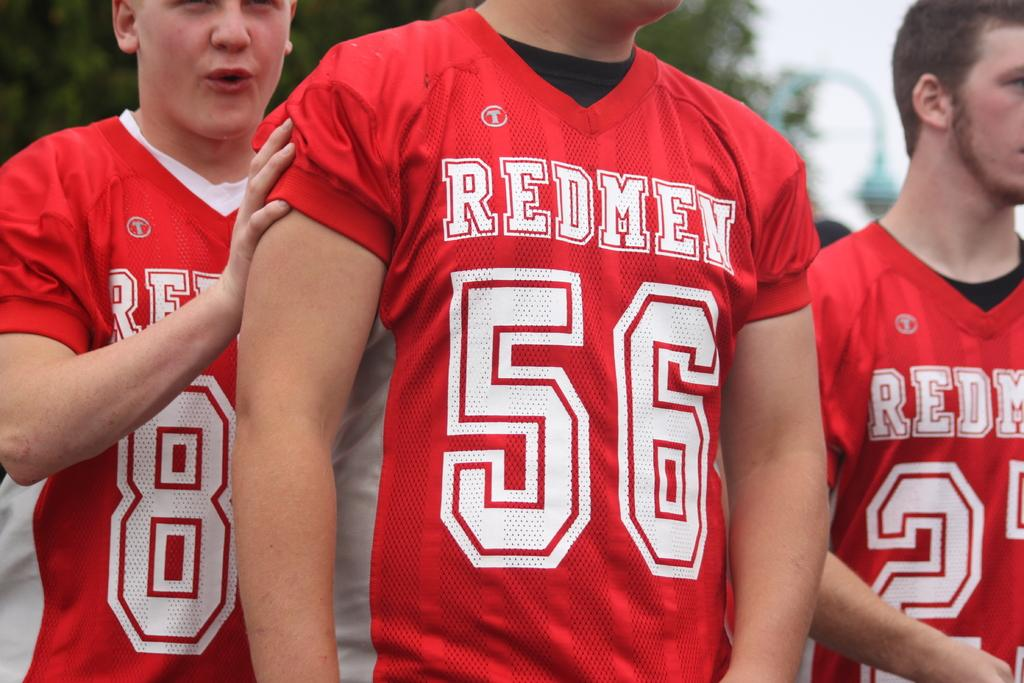<image>
Summarize the visual content of the image. A player wearing a Redmen number 56 jersey alongside two teammates. 